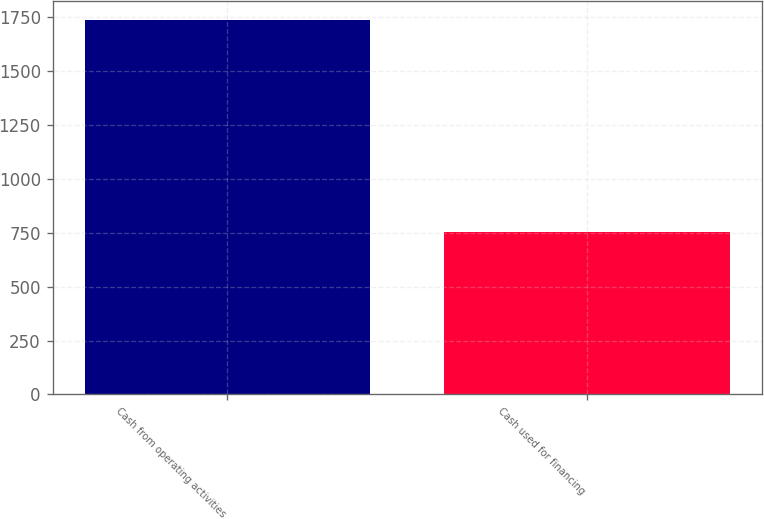Convert chart to OTSL. <chart><loc_0><loc_0><loc_500><loc_500><bar_chart><fcel>Cash from operating activities<fcel>Cash used for financing<nl><fcel>1735<fcel>754<nl></chart> 